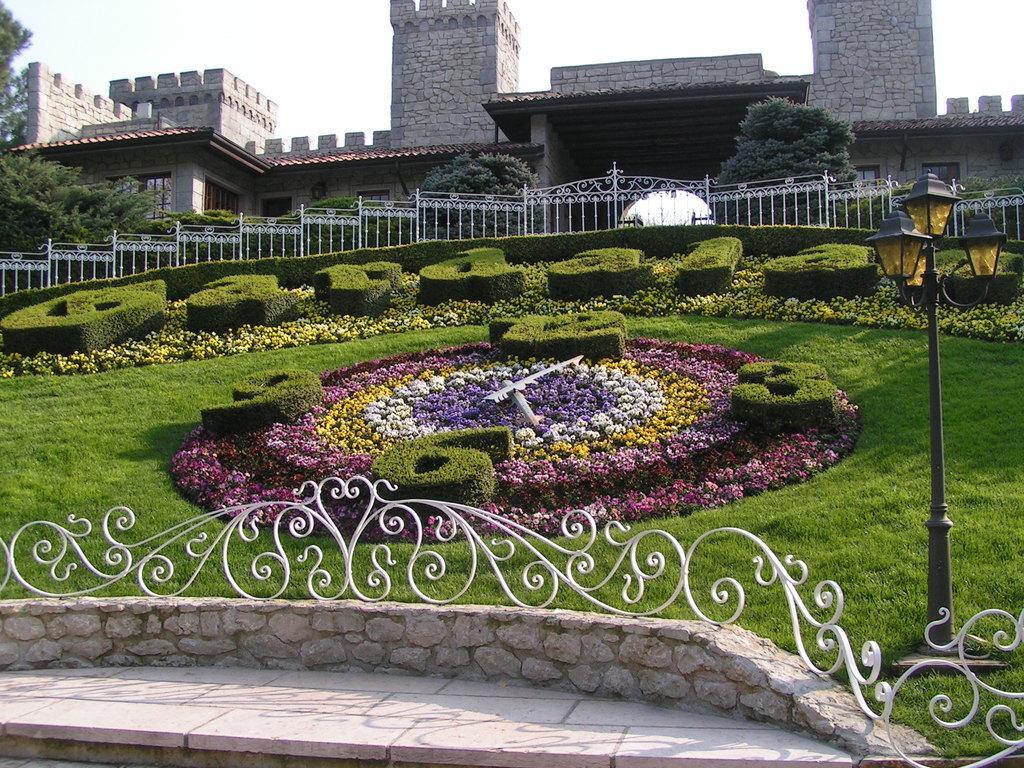Can you describe this image briefly? In this image I can see the railing, few flowers in multi color, grass and trees in green color, few light poles. In the background I can see the building, few glass windows and the sky is in white color. 